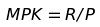Convert formula to latex. <formula><loc_0><loc_0><loc_500><loc_500>M P K = R / P</formula> 